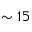<formula> <loc_0><loc_0><loc_500><loc_500>\sim 1 5</formula> 